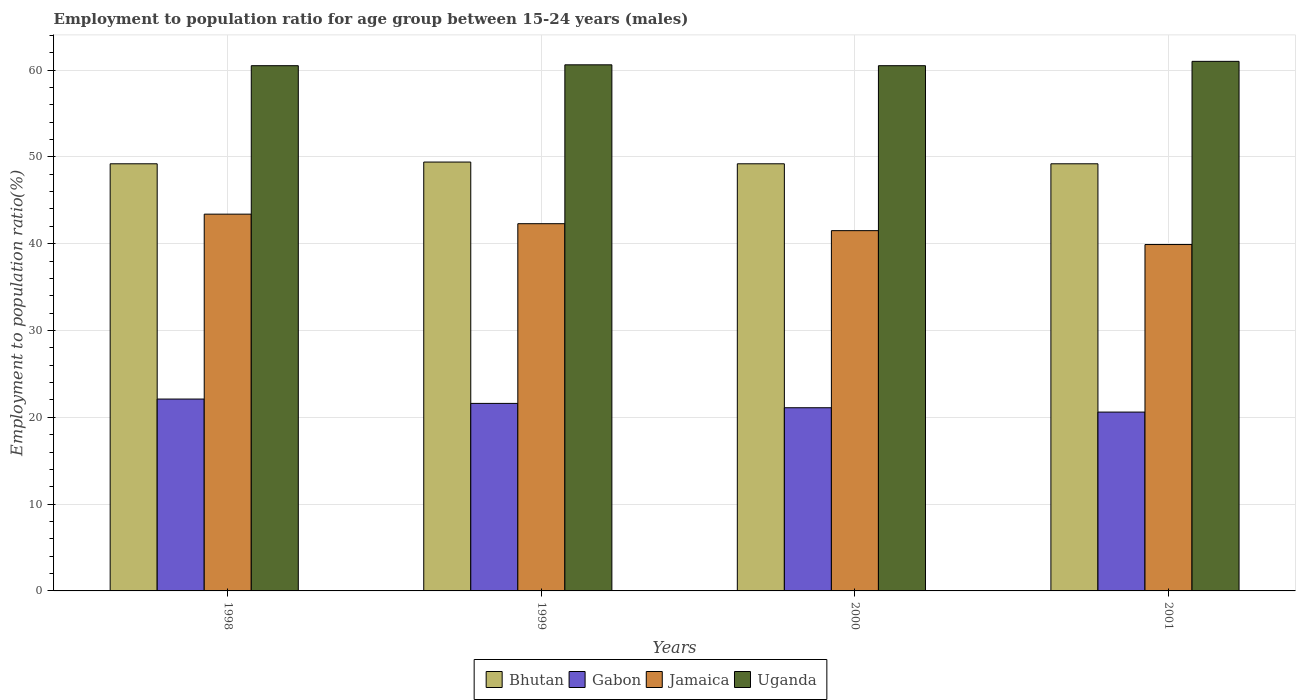How many different coloured bars are there?
Your answer should be compact. 4. How many groups of bars are there?
Your answer should be very brief. 4. How many bars are there on the 3rd tick from the left?
Ensure brevity in your answer.  4. How many bars are there on the 2nd tick from the right?
Make the answer very short. 4. What is the label of the 4th group of bars from the left?
Provide a short and direct response. 2001. What is the employment to population ratio in Uganda in 1998?
Make the answer very short. 60.5. Across all years, what is the maximum employment to population ratio in Uganda?
Offer a very short reply. 61. Across all years, what is the minimum employment to population ratio in Jamaica?
Offer a terse response. 39.9. What is the total employment to population ratio in Bhutan in the graph?
Your answer should be compact. 197. What is the difference between the employment to population ratio in Jamaica in 2001 and the employment to population ratio in Uganda in 1999?
Make the answer very short. -20.7. What is the average employment to population ratio in Uganda per year?
Your answer should be very brief. 60.65. In the year 2000, what is the difference between the employment to population ratio in Uganda and employment to population ratio in Gabon?
Your answer should be compact. 39.4. What is the ratio of the employment to population ratio in Uganda in 1998 to that in 1999?
Keep it short and to the point. 1. Is the employment to population ratio in Jamaica in 1998 less than that in 1999?
Your answer should be compact. No. What is the difference between the highest and the second highest employment to population ratio in Uganda?
Your response must be concise. 0.4. What is the difference between the highest and the lowest employment to population ratio in Bhutan?
Make the answer very short. 0.2. In how many years, is the employment to population ratio in Uganda greater than the average employment to population ratio in Uganda taken over all years?
Make the answer very short. 1. Is it the case that in every year, the sum of the employment to population ratio in Bhutan and employment to population ratio in Jamaica is greater than the sum of employment to population ratio in Gabon and employment to population ratio in Uganda?
Provide a succinct answer. Yes. What does the 2nd bar from the left in 2001 represents?
Ensure brevity in your answer.  Gabon. What does the 4th bar from the right in 2001 represents?
Provide a succinct answer. Bhutan. Is it the case that in every year, the sum of the employment to population ratio in Gabon and employment to population ratio in Bhutan is greater than the employment to population ratio in Uganda?
Keep it short and to the point. Yes. How many years are there in the graph?
Provide a short and direct response. 4. What is the difference between two consecutive major ticks on the Y-axis?
Offer a very short reply. 10. Where does the legend appear in the graph?
Ensure brevity in your answer.  Bottom center. How are the legend labels stacked?
Offer a terse response. Horizontal. What is the title of the graph?
Your response must be concise. Employment to population ratio for age group between 15-24 years (males). Does "Dominica" appear as one of the legend labels in the graph?
Make the answer very short. No. What is the Employment to population ratio(%) of Bhutan in 1998?
Offer a terse response. 49.2. What is the Employment to population ratio(%) of Gabon in 1998?
Provide a short and direct response. 22.1. What is the Employment to population ratio(%) in Jamaica in 1998?
Ensure brevity in your answer.  43.4. What is the Employment to population ratio(%) of Uganda in 1998?
Make the answer very short. 60.5. What is the Employment to population ratio(%) of Bhutan in 1999?
Your answer should be compact. 49.4. What is the Employment to population ratio(%) of Gabon in 1999?
Ensure brevity in your answer.  21.6. What is the Employment to population ratio(%) of Jamaica in 1999?
Give a very brief answer. 42.3. What is the Employment to population ratio(%) of Uganda in 1999?
Your answer should be very brief. 60.6. What is the Employment to population ratio(%) of Bhutan in 2000?
Your answer should be compact. 49.2. What is the Employment to population ratio(%) in Gabon in 2000?
Provide a short and direct response. 21.1. What is the Employment to population ratio(%) of Jamaica in 2000?
Your response must be concise. 41.5. What is the Employment to population ratio(%) in Uganda in 2000?
Keep it short and to the point. 60.5. What is the Employment to population ratio(%) in Bhutan in 2001?
Provide a succinct answer. 49.2. What is the Employment to population ratio(%) of Gabon in 2001?
Ensure brevity in your answer.  20.6. What is the Employment to population ratio(%) of Jamaica in 2001?
Offer a very short reply. 39.9. Across all years, what is the maximum Employment to population ratio(%) of Bhutan?
Give a very brief answer. 49.4. Across all years, what is the maximum Employment to population ratio(%) of Gabon?
Your answer should be compact. 22.1. Across all years, what is the maximum Employment to population ratio(%) in Jamaica?
Offer a very short reply. 43.4. Across all years, what is the minimum Employment to population ratio(%) in Bhutan?
Your response must be concise. 49.2. Across all years, what is the minimum Employment to population ratio(%) of Gabon?
Your answer should be compact. 20.6. Across all years, what is the minimum Employment to population ratio(%) in Jamaica?
Make the answer very short. 39.9. Across all years, what is the minimum Employment to population ratio(%) of Uganda?
Give a very brief answer. 60.5. What is the total Employment to population ratio(%) of Bhutan in the graph?
Offer a very short reply. 197. What is the total Employment to population ratio(%) in Gabon in the graph?
Make the answer very short. 85.4. What is the total Employment to population ratio(%) in Jamaica in the graph?
Your response must be concise. 167.1. What is the total Employment to population ratio(%) in Uganda in the graph?
Your answer should be very brief. 242.6. What is the difference between the Employment to population ratio(%) of Bhutan in 1998 and that in 1999?
Your answer should be very brief. -0.2. What is the difference between the Employment to population ratio(%) of Uganda in 1998 and that in 1999?
Your answer should be compact. -0.1. What is the difference between the Employment to population ratio(%) of Jamaica in 1998 and that in 2000?
Provide a short and direct response. 1.9. What is the difference between the Employment to population ratio(%) in Bhutan in 1998 and that in 2001?
Offer a very short reply. 0. What is the difference between the Employment to population ratio(%) of Jamaica in 1998 and that in 2001?
Ensure brevity in your answer.  3.5. What is the difference between the Employment to population ratio(%) of Uganda in 1998 and that in 2001?
Make the answer very short. -0.5. What is the difference between the Employment to population ratio(%) in Jamaica in 1999 and that in 2000?
Provide a short and direct response. 0.8. What is the difference between the Employment to population ratio(%) in Bhutan in 1999 and that in 2001?
Your response must be concise. 0.2. What is the difference between the Employment to population ratio(%) in Uganda in 1999 and that in 2001?
Ensure brevity in your answer.  -0.4. What is the difference between the Employment to population ratio(%) in Jamaica in 2000 and that in 2001?
Your answer should be compact. 1.6. What is the difference between the Employment to population ratio(%) of Uganda in 2000 and that in 2001?
Provide a short and direct response. -0.5. What is the difference between the Employment to population ratio(%) in Bhutan in 1998 and the Employment to population ratio(%) in Gabon in 1999?
Keep it short and to the point. 27.6. What is the difference between the Employment to population ratio(%) of Bhutan in 1998 and the Employment to population ratio(%) of Jamaica in 1999?
Provide a succinct answer. 6.9. What is the difference between the Employment to population ratio(%) of Gabon in 1998 and the Employment to population ratio(%) of Jamaica in 1999?
Ensure brevity in your answer.  -20.2. What is the difference between the Employment to population ratio(%) of Gabon in 1998 and the Employment to population ratio(%) of Uganda in 1999?
Your answer should be compact. -38.5. What is the difference between the Employment to population ratio(%) in Jamaica in 1998 and the Employment to population ratio(%) in Uganda in 1999?
Make the answer very short. -17.2. What is the difference between the Employment to population ratio(%) in Bhutan in 1998 and the Employment to population ratio(%) in Gabon in 2000?
Your answer should be compact. 28.1. What is the difference between the Employment to population ratio(%) in Gabon in 1998 and the Employment to population ratio(%) in Jamaica in 2000?
Offer a very short reply. -19.4. What is the difference between the Employment to population ratio(%) in Gabon in 1998 and the Employment to population ratio(%) in Uganda in 2000?
Your response must be concise. -38.4. What is the difference between the Employment to population ratio(%) of Jamaica in 1998 and the Employment to population ratio(%) of Uganda in 2000?
Provide a succinct answer. -17.1. What is the difference between the Employment to population ratio(%) in Bhutan in 1998 and the Employment to population ratio(%) in Gabon in 2001?
Your answer should be compact. 28.6. What is the difference between the Employment to population ratio(%) in Bhutan in 1998 and the Employment to population ratio(%) in Uganda in 2001?
Provide a succinct answer. -11.8. What is the difference between the Employment to population ratio(%) in Gabon in 1998 and the Employment to population ratio(%) in Jamaica in 2001?
Give a very brief answer. -17.8. What is the difference between the Employment to population ratio(%) of Gabon in 1998 and the Employment to population ratio(%) of Uganda in 2001?
Give a very brief answer. -38.9. What is the difference between the Employment to population ratio(%) in Jamaica in 1998 and the Employment to population ratio(%) in Uganda in 2001?
Your answer should be very brief. -17.6. What is the difference between the Employment to population ratio(%) in Bhutan in 1999 and the Employment to population ratio(%) in Gabon in 2000?
Offer a terse response. 28.3. What is the difference between the Employment to population ratio(%) in Gabon in 1999 and the Employment to population ratio(%) in Jamaica in 2000?
Your response must be concise. -19.9. What is the difference between the Employment to population ratio(%) of Gabon in 1999 and the Employment to population ratio(%) of Uganda in 2000?
Offer a very short reply. -38.9. What is the difference between the Employment to population ratio(%) in Jamaica in 1999 and the Employment to population ratio(%) in Uganda in 2000?
Your answer should be very brief. -18.2. What is the difference between the Employment to population ratio(%) in Bhutan in 1999 and the Employment to population ratio(%) in Gabon in 2001?
Provide a succinct answer. 28.8. What is the difference between the Employment to population ratio(%) in Bhutan in 1999 and the Employment to population ratio(%) in Uganda in 2001?
Provide a short and direct response. -11.6. What is the difference between the Employment to population ratio(%) of Gabon in 1999 and the Employment to population ratio(%) of Jamaica in 2001?
Keep it short and to the point. -18.3. What is the difference between the Employment to population ratio(%) of Gabon in 1999 and the Employment to population ratio(%) of Uganda in 2001?
Make the answer very short. -39.4. What is the difference between the Employment to population ratio(%) of Jamaica in 1999 and the Employment to population ratio(%) of Uganda in 2001?
Ensure brevity in your answer.  -18.7. What is the difference between the Employment to population ratio(%) of Bhutan in 2000 and the Employment to population ratio(%) of Gabon in 2001?
Offer a terse response. 28.6. What is the difference between the Employment to population ratio(%) of Bhutan in 2000 and the Employment to population ratio(%) of Uganda in 2001?
Give a very brief answer. -11.8. What is the difference between the Employment to population ratio(%) of Gabon in 2000 and the Employment to population ratio(%) of Jamaica in 2001?
Keep it short and to the point. -18.8. What is the difference between the Employment to population ratio(%) of Gabon in 2000 and the Employment to population ratio(%) of Uganda in 2001?
Your answer should be compact. -39.9. What is the difference between the Employment to population ratio(%) in Jamaica in 2000 and the Employment to population ratio(%) in Uganda in 2001?
Your answer should be very brief. -19.5. What is the average Employment to population ratio(%) of Bhutan per year?
Make the answer very short. 49.25. What is the average Employment to population ratio(%) of Gabon per year?
Your answer should be very brief. 21.35. What is the average Employment to population ratio(%) of Jamaica per year?
Make the answer very short. 41.77. What is the average Employment to population ratio(%) of Uganda per year?
Your answer should be compact. 60.65. In the year 1998, what is the difference between the Employment to population ratio(%) in Bhutan and Employment to population ratio(%) in Gabon?
Your answer should be very brief. 27.1. In the year 1998, what is the difference between the Employment to population ratio(%) in Bhutan and Employment to population ratio(%) in Uganda?
Provide a short and direct response. -11.3. In the year 1998, what is the difference between the Employment to population ratio(%) in Gabon and Employment to population ratio(%) in Jamaica?
Keep it short and to the point. -21.3. In the year 1998, what is the difference between the Employment to population ratio(%) in Gabon and Employment to population ratio(%) in Uganda?
Give a very brief answer. -38.4. In the year 1998, what is the difference between the Employment to population ratio(%) of Jamaica and Employment to population ratio(%) of Uganda?
Give a very brief answer. -17.1. In the year 1999, what is the difference between the Employment to population ratio(%) of Bhutan and Employment to population ratio(%) of Gabon?
Provide a short and direct response. 27.8. In the year 1999, what is the difference between the Employment to population ratio(%) in Gabon and Employment to population ratio(%) in Jamaica?
Provide a succinct answer. -20.7. In the year 1999, what is the difference between the Employment to population ratio(%) in Gabon and Employment to population ratio(%) in Uganda?
Offer a very short reply. -39. In the year 1999, what is the difference between the Employment to population ratio(%) of Jamaica and Employment to population ratio(%) of Uganda?
Provide a succinct answer. -18.3. In the year 2000, what is the difference between the Employment to population ratio(%) of Bhutan and Employment to population ratio(%) of Gabon?
Your answer should be compact. 28.1. In the year 2000, what is the difference between the Employment to population ratio(%) in Bhutan and Employment to population ratio(%) in Uganda?
Make the answer very short. -11.3. In the year 2000, what is the difference between the Employment to population ratio(%) of Gabon and Employment to population ratio(%) of Jamaica?
Give a very brief answer. -20.4. In the year 2000, what is the difference between the Employment to population ratio(%) in Gabon and Employment to population ratio(%) in Uganda?
Offer a terse response. -39.4. In the year 2001, what is the difference between the Employment to population ratio(%) in Bhutan and Employment to population ratio(%) in Gabon?
Your answer should be compact. 28.6. In the year 2001, what is the difference between the Employment to population ratio(%) in Bhutan and Employment to population ratio(%) in Uganda?
Ensure brevity in your answer.  -11.8. In the year 2001, what is the difference between the Employment to population ratio(%) in Gabon and Employment to population ratio(%) in Jamaica?
Ensure brevity in your answer.  -19.3. In the year 2001, what is the difference between the Employment to population ratio(%) in Gabon and Employment to population ratio(%) in Uganda?
Offer a terse response. -40.4. In the year 2001, what is the difference between the Employment to population ratio(%) of Jamaica and Employment to population ratio(%) of Uganda?
Your answer should be very brief. -21.1. What is the ratio of the Employment to population ratio(%) of Gabon in 1998 to that in 1999?
Your answer should be very brief. 1.02. What is the ratio of the Employment to population ratio(%) in Jamaica in 1998 to that in 1999?
Offer a terse response. 1.03. What is the ratio of the Employment to population ratio(%) in Uganda in 1998 to that in 1999?
Give a very brief answer. 1. What is the ratio of the Employment to population ratio(%) of Bhutan in 1998 to that in 2000?
Your response must be concise. 1. What is the ratio of the Employment to population ratio(%) of Gabon in 1998 to that in 2000?
Offer a very short reply. 1.05. What is the ratio of the Employment to population ratio(%) in Jamaica in 1998 to that in 2000?
Make the answer very short. 1.05. What is the ratio of the Employment to population ratio(%) in Bhutan in 1998 to that in 2001?
Provide a short and direct response. 1. What is the ratio of the Employment to population ratio(%) in Gabon in 1998 to that in 2001?
Ensure brevity in your answer.  1.07. What is the ratio of the Employment to population ratio(%) of Jamaica in 1998 to that in 2001?
Keep it short and to the point. 1.09. What is the ratio of the Employment to population ratio(%) in Bhutan in 1999 to that in 2000?
Offer a very short reply. 1. What is the ratio of the Employment to population ratio(%) in Gabon in 1999 to that in 2000?
Provide a succinct answer. 1.02. What is the ratio of the Employment to population ratio(%) in Jamaica in 1999 to that in 2000?
Your answer should be very brief. 1.02. What is the ratio of the Employment to population ratio(%) in Uganda in 1999 to that in 2000?
Provide a short and direct response. 1. What is the ratio of the Employment to population ratio(%) of Gabon in 1999 to that in 2001?
Your response must be concise. 1.05. What is the ratio of the Employment to population ratio(%) in Jamaica in 1999 to that in 2001?
Make the answer very short. 1.06. What is the ratio of the Employment to population ratio(%) of Uganda in 1999 to that in 2001?
Your answer should be compact. 0.99. What is the ratio of the Employment to population ratio(%) in Gabon in 2000 to that in 2001?
Provide a short and direct response. 1.02. What is the ratio of the Employment to population ratio(%) of Jamaica in 2000 to that in 2001?
Ensure brevity in your answer.  1.04. What is the difference between the highest and the second highest Employment to population ratio(%) of Jamaica?
Offer a very short reply. 1.1. What is the difference between the highest and the second highest Employment to population ratio(%) in Uganda?
Ensure brevity in your answer.  0.4. What is the difference between the highest and the lowest Employment to population ratio(%) in Bhutan?
Ensure brevity in your answer.  0.2. What is the difference between the highest and the lowest Employment to population ratio(%) of Uganda?
Keep it short and to the point. 0.5. 